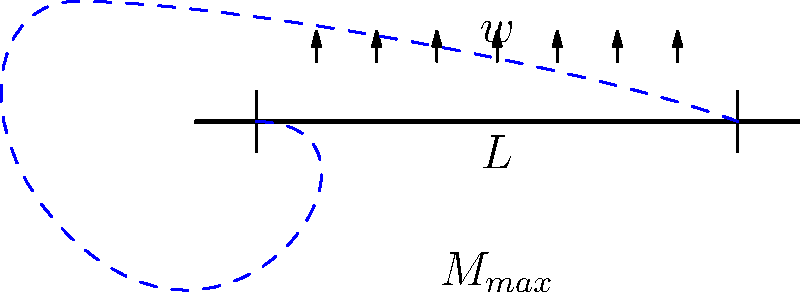In a simply supported beam of length $L$ with a uniformly distributed load $w$, what is the maximum bending moment $M_{max}$ in terms of $w$ and $L$? To find the maximum bending moment in a simply supported beam with a uniformly distributed load, we can follow these steps:

1. Identify the load and support conditions:
   - Uniformly distributed load $w$ across the entire span
   - Simple supports at both ends

2. Determine the reactions at the supports:
   - Due to symmetry, each support reaction $R = \frac{wL}{2}$

3. Analyze the bending moment distribution:
   - The bending moment varies parabolically along the beam
   - Maximum bending moment occurs at the center of the beam

4. Calculate the maximum bending moment:
   - Using the formula for maximum bending moment in this case:
     $$M_{max} = \frac{wL^2}{8}$$

This formula represents the peak of the parabolic bending moment diagram, which occurs at the center of the beam. The factor of 8 in the denominator comes from the integration of the distributed load effect over half the span of the beam.
Answer: $M_{max} = \frac{wL^2}{8}$ 